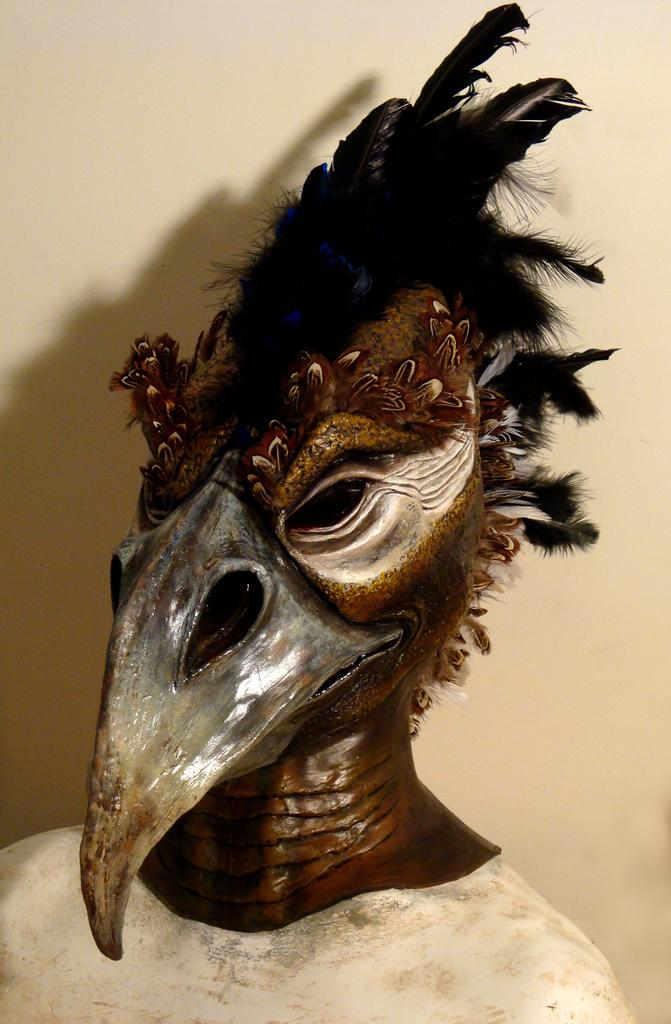What is the main subject of the image? There is a sculpture in the image. Can you describe the setting of the image? There is a wall in the background of the image. What statement does the cow make in the image? There is no cow present in the image, so it cannot make any statements. 